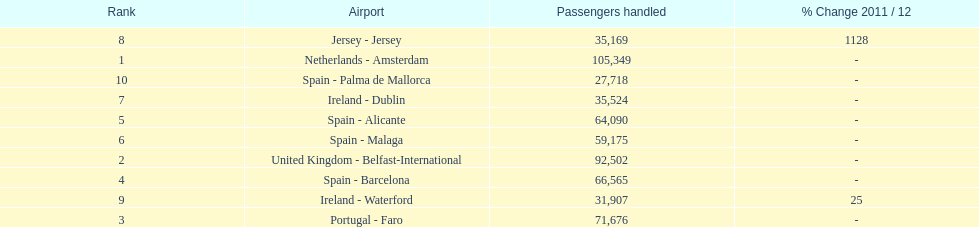Which airport has the least amount of passengers going through london southend airport? Spain - Palma de Mallorca. 